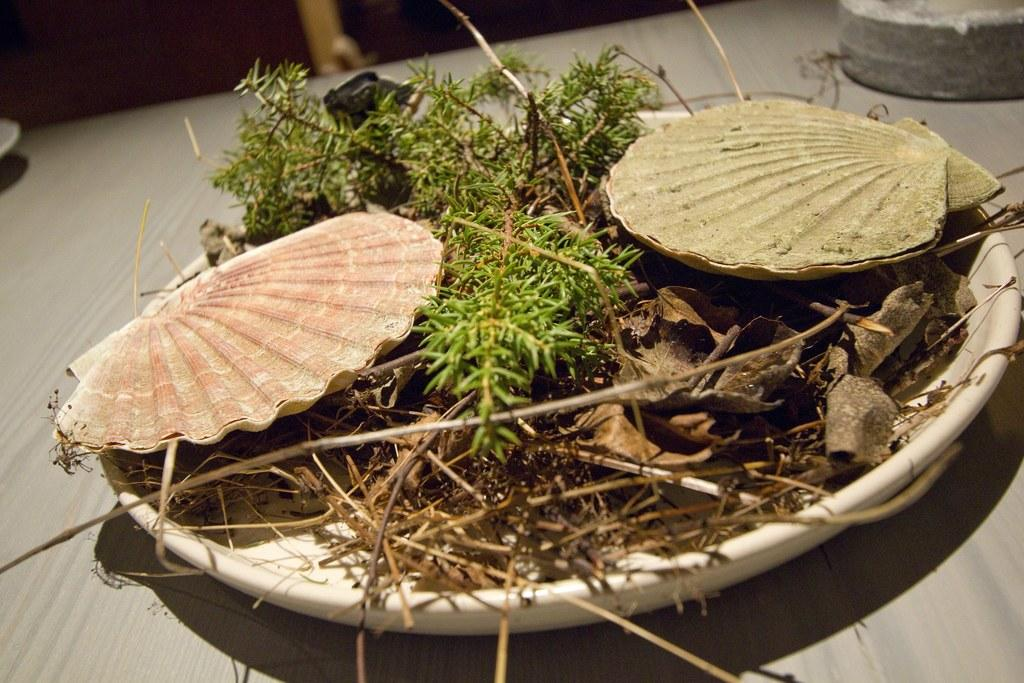What type of object is made of plastic in the image? There is a plastic object in the image. What is inside the plastic object? The plastic object is filled with leaves, dry grass, and stems. What theory is being tested in the image? There is no theory being tested in the image; it features a plastic object filled with leaves, dry grass, and stems. What type of button can be seen on the plastic object? There is no button present on the plastic object in the image. 